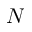Convert formula to latex. <formula><loc_0><loc_0><loc_500><loc_500>N</formula> 